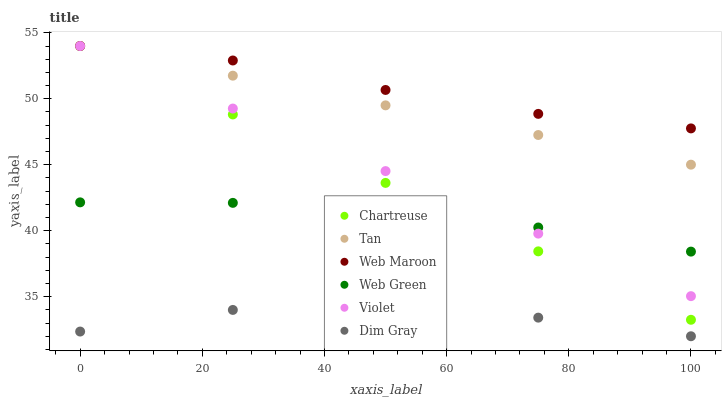Does Dim Gray have the minimum area under the curve?
Answer yes or no. Yes. Does Web Maroon have the maximum area under the curve?
Answer yes or no. Yes. Does Web Green have the minimum area under the curve?
Answer yes or no. No. Does Web Green have the maximum area under the curve?
Answer yes or no. No. Is Chartreuse the smoothest?
Answer yes or no. Yes. Is Dim Gray the roughest?
Answer yes or no. Yes. Is Web Maroon the smoothest?
Answer yes or no. No. Is Web Maroon the roughest?
Answer yes or no. No. Does Dim Gray have the lowest value?
Answer yes or no. Yes. Does Web Green have the lowest value?
Answer yes or no. No. Does Tan have the highest value?
Answer yes or no. Yes. Does Web Green have the highest value?
Answer yes or no. No. Is Web Green less than Tan?
Answer yes or no. Yes. Is Violet greater than Dim Gray?
Answer yes or no. Yes. Does Violet intersect Web Green?
Answer yes or no. Yes. Is Violet less than Web Green?
Answer yes or no. No. Is Violet greater than Web Green?
Answer yes or no. No. Does Web Green intersect Tan?
Answer yes or no. No. 